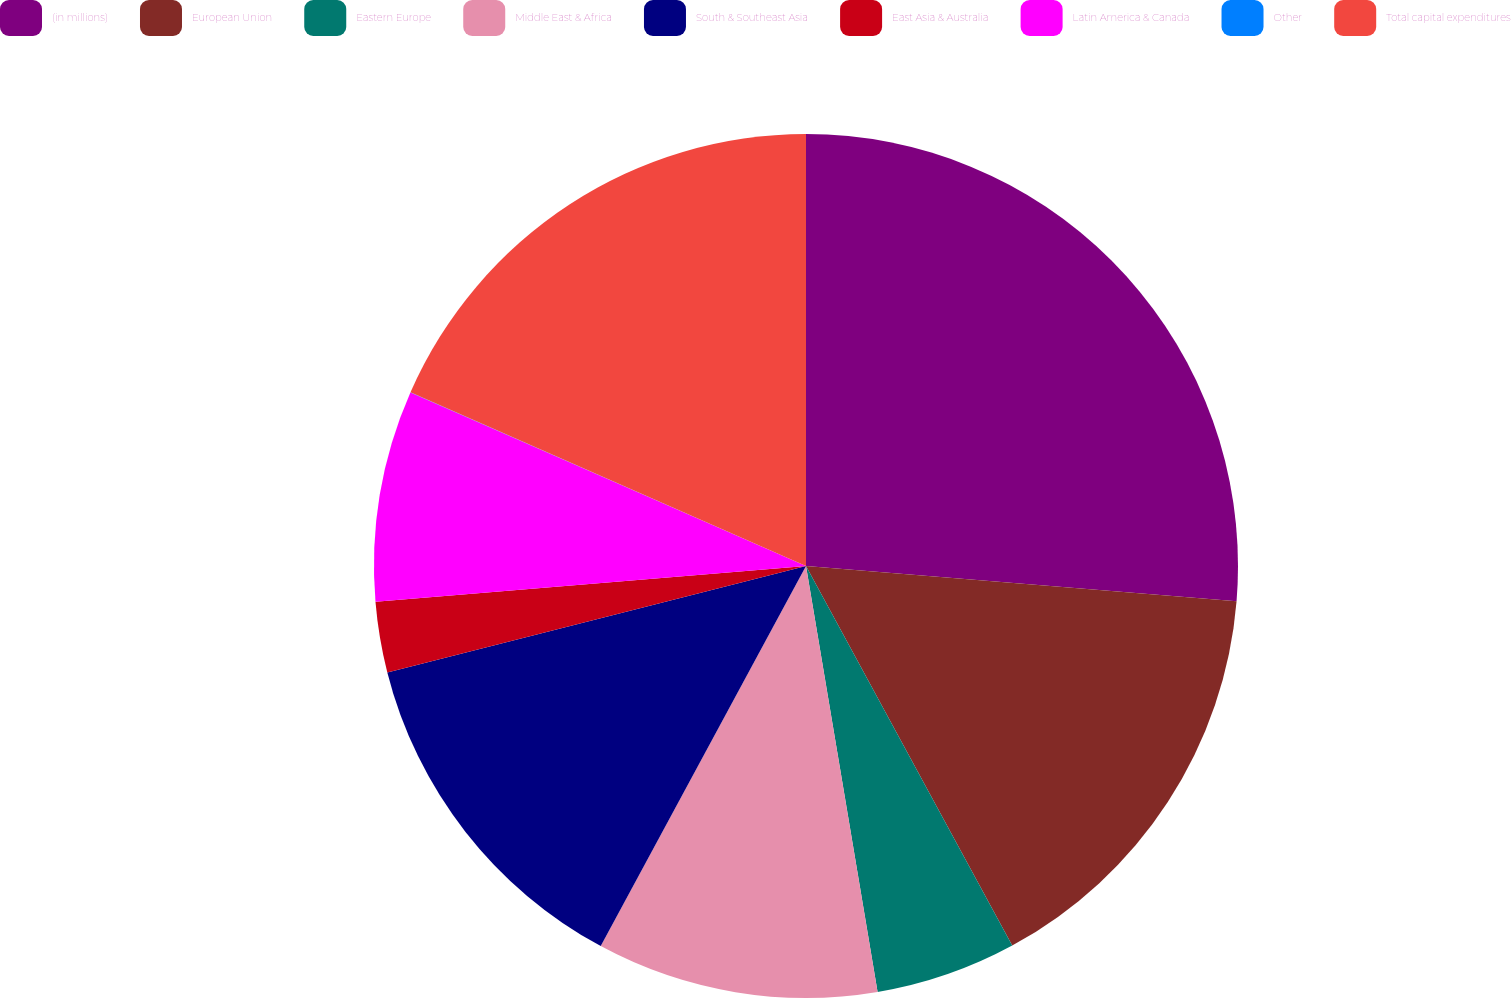Convert chart to OTSL. <chart><loc_0><loc_0><loc_500><loc_500><pie_chart><fcel>(in millions)<fcel>European Union<fcel>Eastern Europe<fcel>Middle East & Africa<fcel>South & Southeast Asia<fcel>East Asia & Australia<fcel>Latin America & Canada<fcel>Other<fcel>Total capital expenditures<nl><fcel>26.3%<fcel>15.78%<fcel>5.27%<fcel>10.53%<fcel>13.16%<fcel>2.64%<fcel>7.9%<fcel>0.01%<fcel>18.41%<nl></chart> 